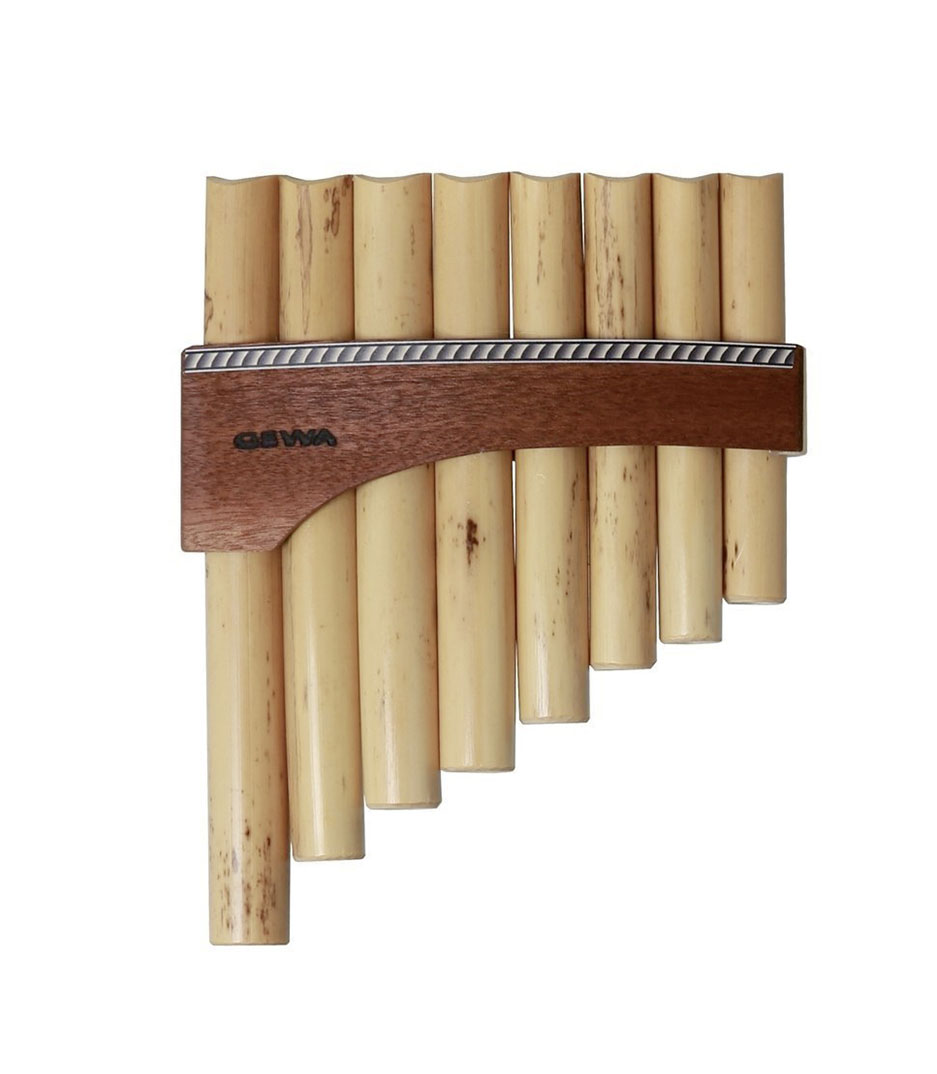Given the variation in length of the pipes and their arrangement, what might be the range of notes this pan flute can play, and how does the length of each pipe correlate to the pitch produced? The range of notes that this pan flute can produce is primarily determined by the lengths of its individual pipes. In general, longer pipes on the instrument produce lower pitches, while shorter pipes yield higher pitches. This is due to the physics of sound and resonance: each pipe functions as a closed tube resonator, where the length of the air column directly affects the pitch. Given the marked variation in pipe lengths visible in the image, this pan flute likely covers a note range that spans at least one octave, potentially extending further depending on the specific lengths of the pipes. Understanding this principle explains why traditional uses of pan flutes in world music are able to create such rich and melodic soundscapes. Each variation in the length of the pipes allows for a diverse array of notes, contributing to the instrument's unique sound. 